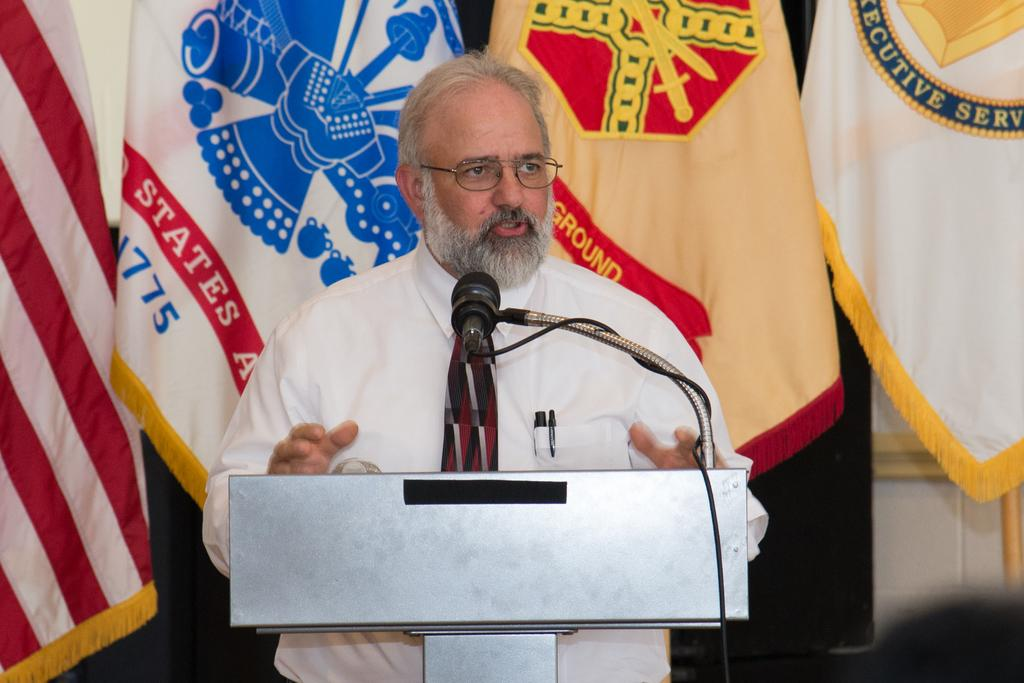<image>
Render a clear and concise summary of the photo. a man standing in front of a flag that has 775 on it 